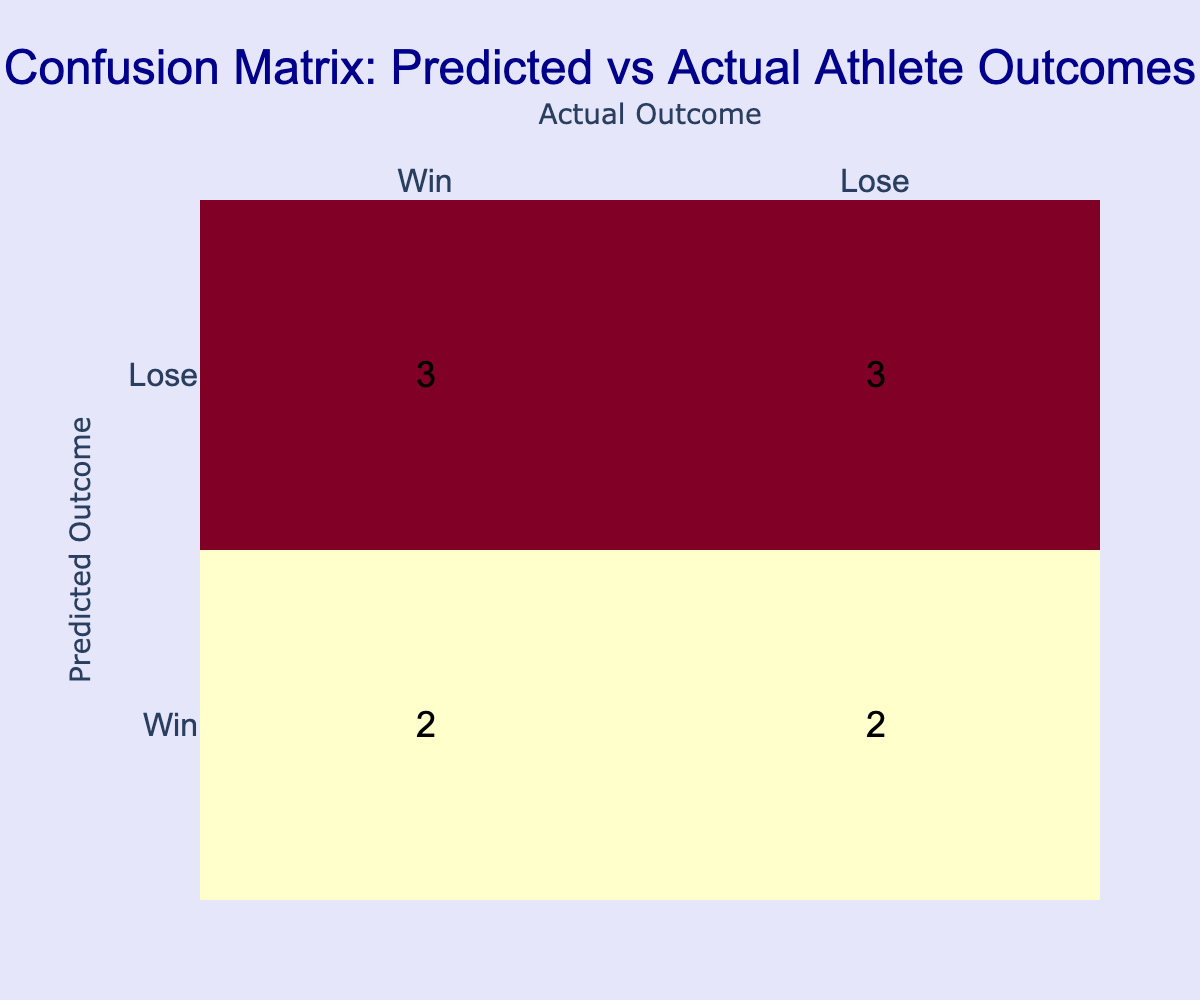What is the total number of wins predicted by the model? To find the total number of wins predicted, we look at the "Win" row in the predicted outcomes. The values under this row are 4 (Win vs. Win), 1 (Win vs. Lose), 1 (Win vs. Lose), and 1 (Win vs. Win), giving us a total of 4 + 1 + 1 + 4 = 6 predicted wins.
Answer: 6 What is the number of true positives from the confusion matrix? True positives are defined as the cases where the predicted outcome is "Win" and the actual outcome is also "Win." From the matrix, there are 4 instances in the Win vs. Win cell, so the number of true positives is 4.
Answer: 4 What is the total number of losses predicted by the model? To find the total number of losses predicted, we look at the "Lose" row in the predicted outcomes. The values under this row are 1 (Lose vs. Win), 1 (Lose vs. Lose), 1 (Lose vs. Win), leading to a total of 1 + 1 + 1 = 3 predicted losses.
Answer: 3 Is the model more accurate in predicting wins than losses? To assess the accuracy, we can compare the ratio of true outcomes to total predictions for both categories. The number of true wins is 4, while the number of true losses is again 4. Since both true outcomes for wins and losses are equal, we can conclude that the model is equally accurate in predicting both.
Answer: No What percentage of the model's predictions were correct? To calculate the percentage of correct predictions, we need to sum the diagonal values (true positives and true negatives) from the confusion matrix: 4 (true positive wins) + 3 (true negative losses) = 7. The total number of predictions is 10. Thus, the accuracy is (7 / 10) * 100 = 70%.
Answer: 70% How many actual wins were misclassified by the model? Misclassifications for actual wins occur when the actual outcome is "Win" but the predicted outcome is "Lose." Referring to the confusion matrix, there are 2 instances in the Lose vs. Win cell where actual wins were misclassified. Thus, the total misclassifications for actual wins is 2.
Answer: 2 What is the difference between predicted wins and predicted losses? The predicted wins total is 6, and the predicted losses total is 3. To find the difference, we subtract the predicted losses from the predicted wins: 6 - 3 = 3.
Answer: 3 What is the number of true negatives in the confusion matrix? True negatives occur where the predicted outcome is "Lose," and the actual outcome is "Lose." Referring to the confusion matrix, there are 3 instances in the Lose vs. Lose cell, hence the number of true negatives is 3.
Answer: 3 